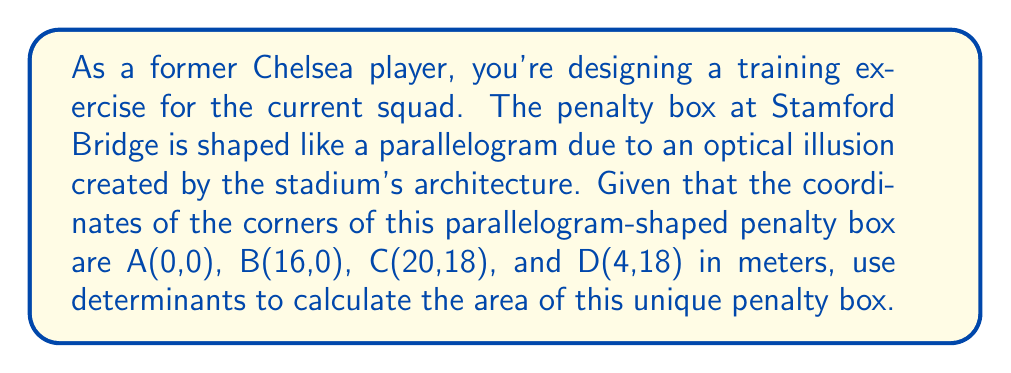Help me with this question. To solve this problem, we'll use the determinant method to find the area of a parallelogram. The steps are as follows:

1) The area of a parallelogram can be calculated using the determinant of two adjacent sides:

   $$\text{Area} = |\det(\overrightarrow{AB}, \overrightarrow{AD})|$$

2) First, let's find the vectors $\overrightarrow{AB}$ and $\overrightarrow{AD}$:
   
   $\overrightarrow{AB} = B - A = (16,0) - (0,0) = (16,0)$
   $\overrightarrow{AD} = D - A = (4,18) - (0,0) = (4,18)$

3) Now, let's set up the determinant:

   $$\det(\overrightarrow{AB}, \overrightarrow{AD}) = \det\begin{pmatrix}
   16 & 4 \\
   0 & 18
   \end{pmatrix}$$

4) Calculate the determinant:

   $$\det\begin{pmatrix}
   16 & 4 \\
   0 & 18
   \end{pmatrix} = (16 \times 18) - (4 \times 0) = 288 - 0 = 288$$

5) The absolute value of this determinant gives us the area:

   Area = $|288| = 288$ square meters

Therefore, the area of the penalty box is 288 square meters.
Answer: 288 m² 